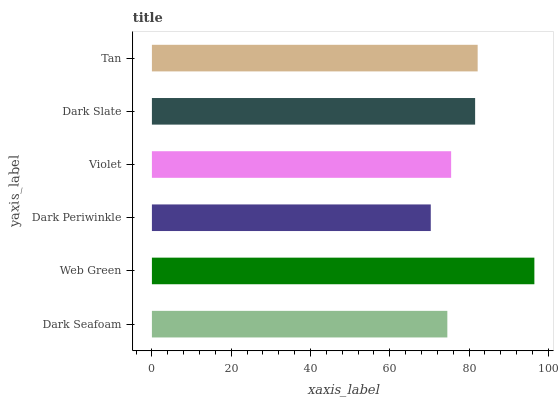Is Dark Periwinkle the minimum?
Answer yes or no. Yes. Is Web Green the maximum?
Answer yes or no. Yes. Is Web Green the minimum?
Answer yes or no. No. Is Dark Periwinkle the maximum?
Answer yes or no. No. Is Web Green greater than Dark Periwinkle?
Answer yes or no. Yes. Is Dark Periwinkle less than Web Green?
Answer yes or no. Yes. Is Dark Periwinkle greater than Web Green?
Answer yes or no. No. Is Web Green less than Dark Periwinkle?
Answer yes or no. No. Is Dark Slate the high median?
Answer yes or no. Yes. Is Violet the low median?
Answer yes or no. Yes. Is Web Green the high median?
Answer yes or no. No. Is Dark Slate the low median?
Answer yes or no. No. 